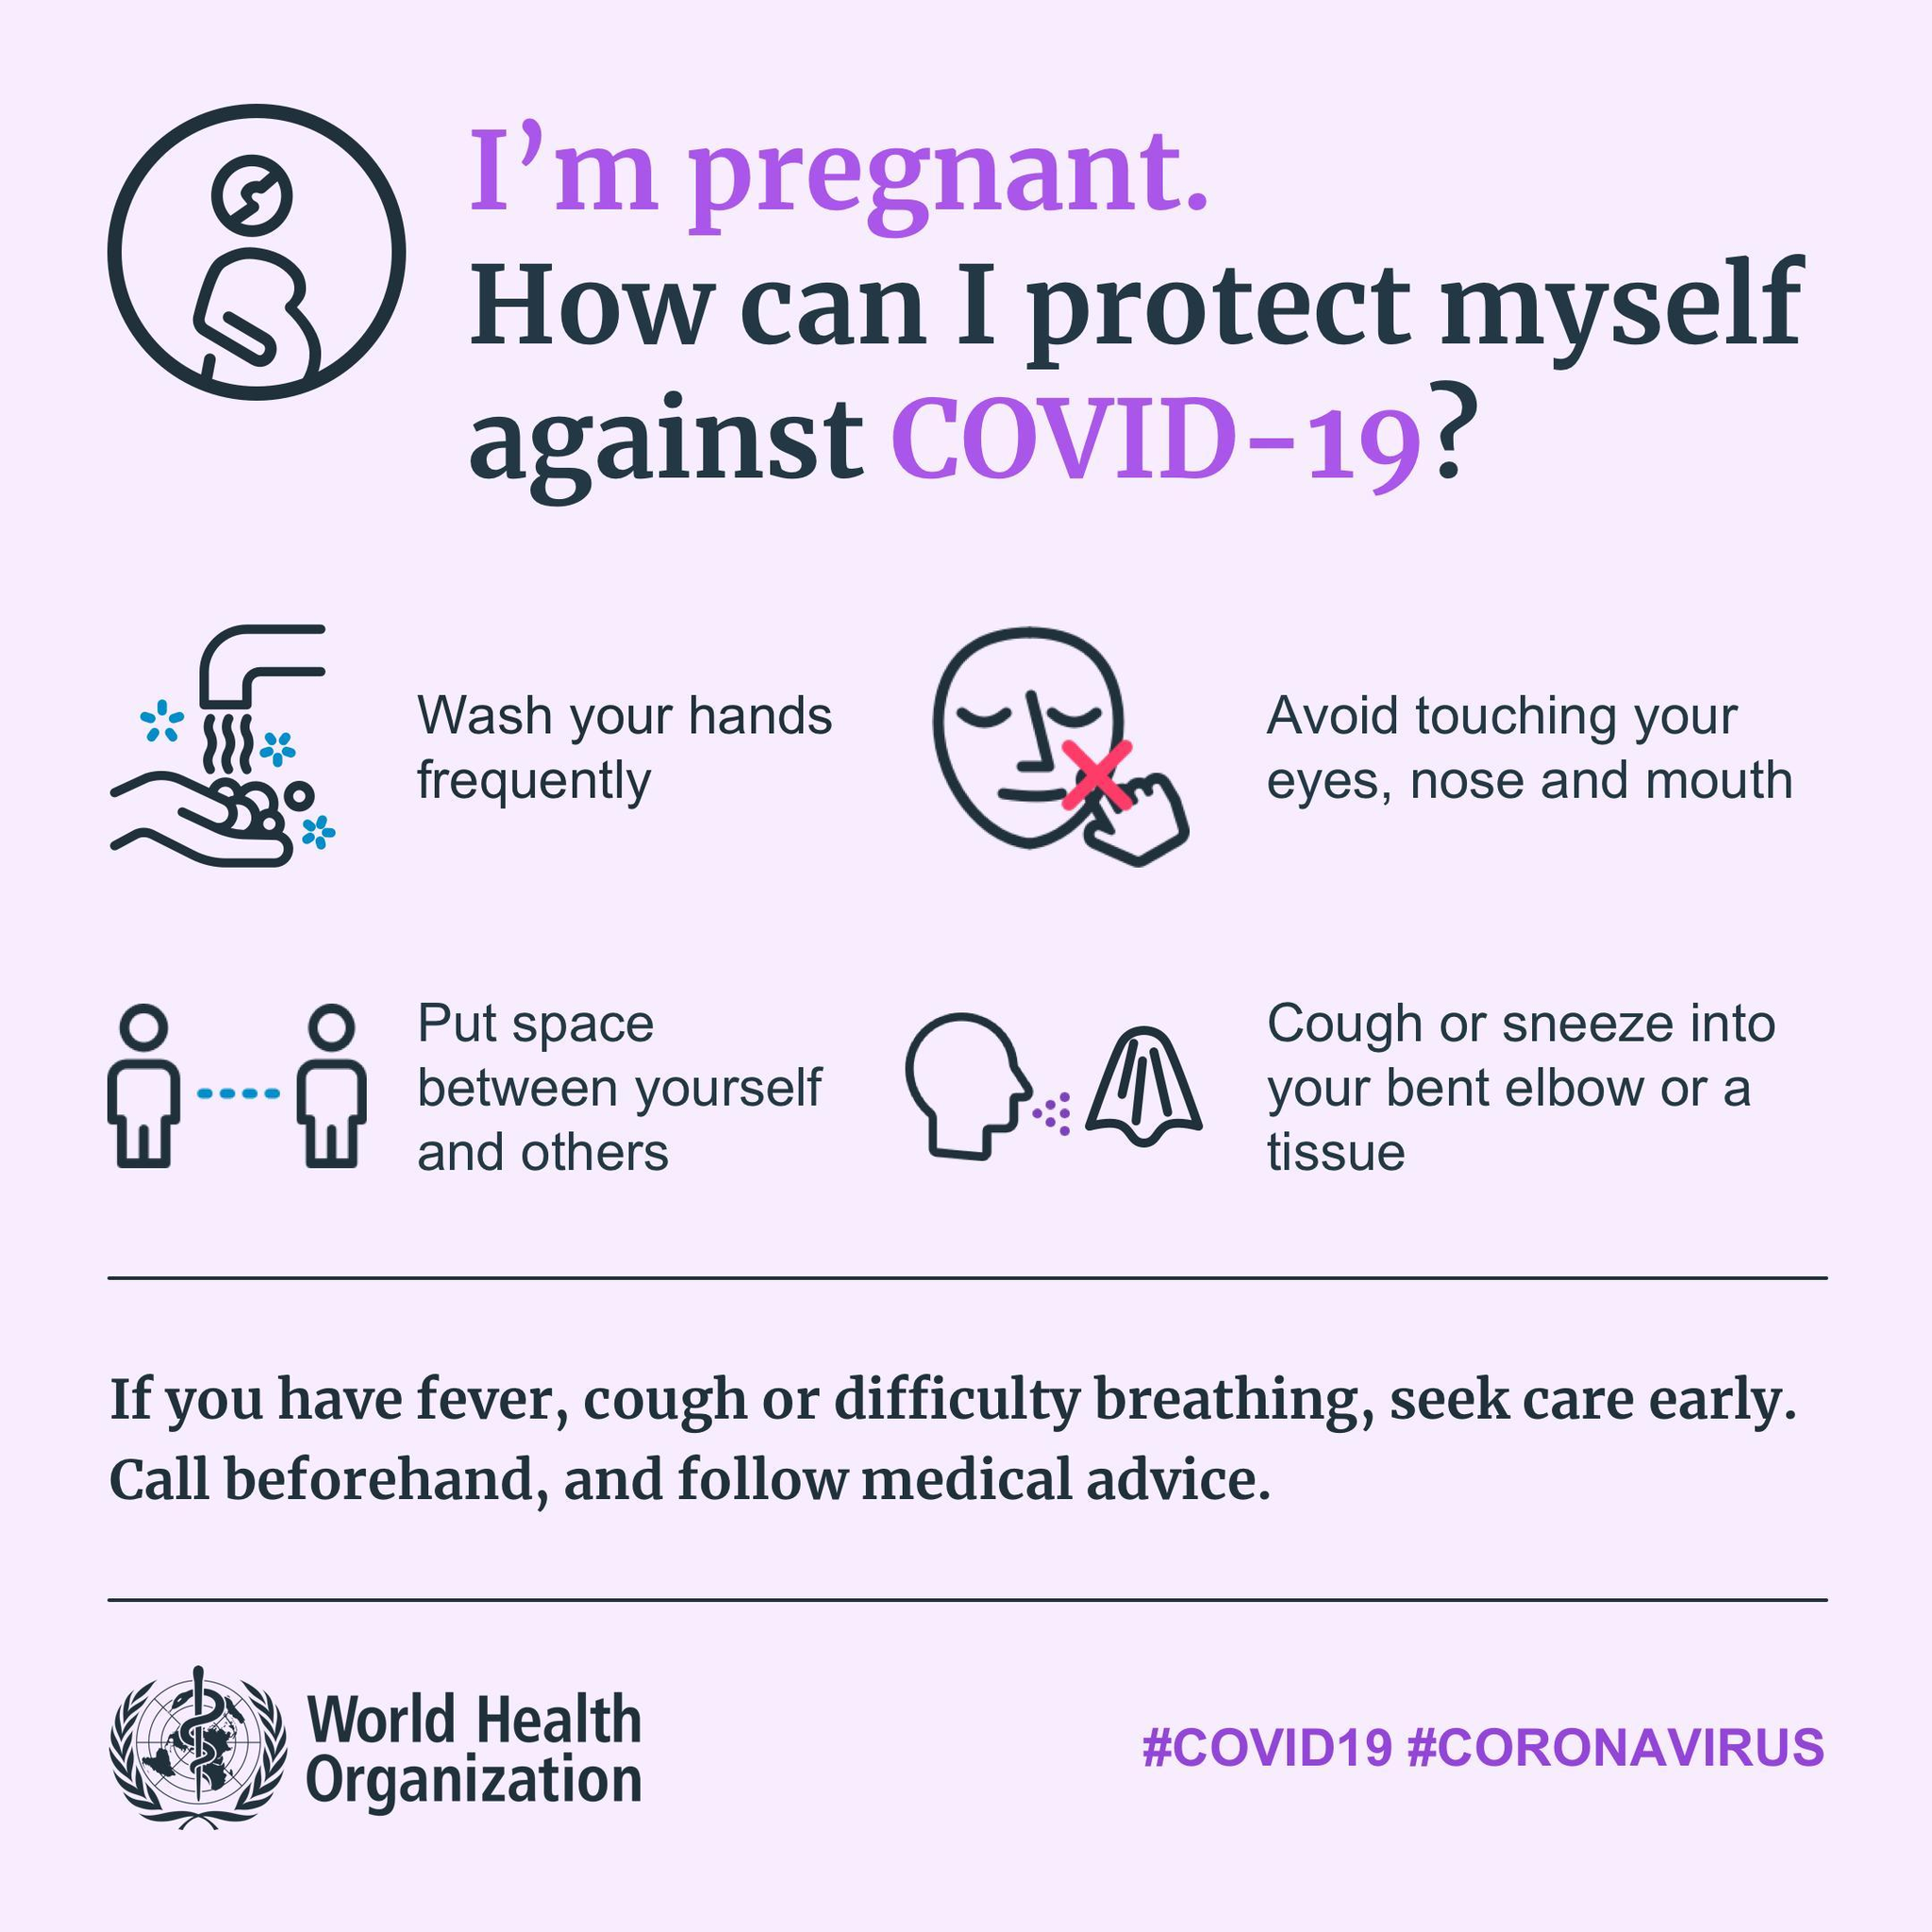What are the hashtags mentioned?
Answer the question with a short phrase. #COVID19, #CORONAVIRUS 